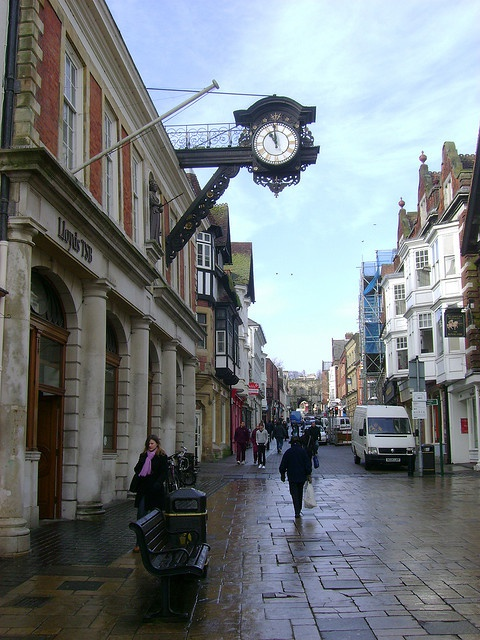Describe the objects in this image and their specific colors. I can see bench in darkgray, black, and gray tones, truck in darkgray, black, and gray tones, people in darkgray, black, gray, and purple tones, clock in darkgray, white, gray, and lightgray tones, and people in darkgray, black, gray, and blue tones in this image. 